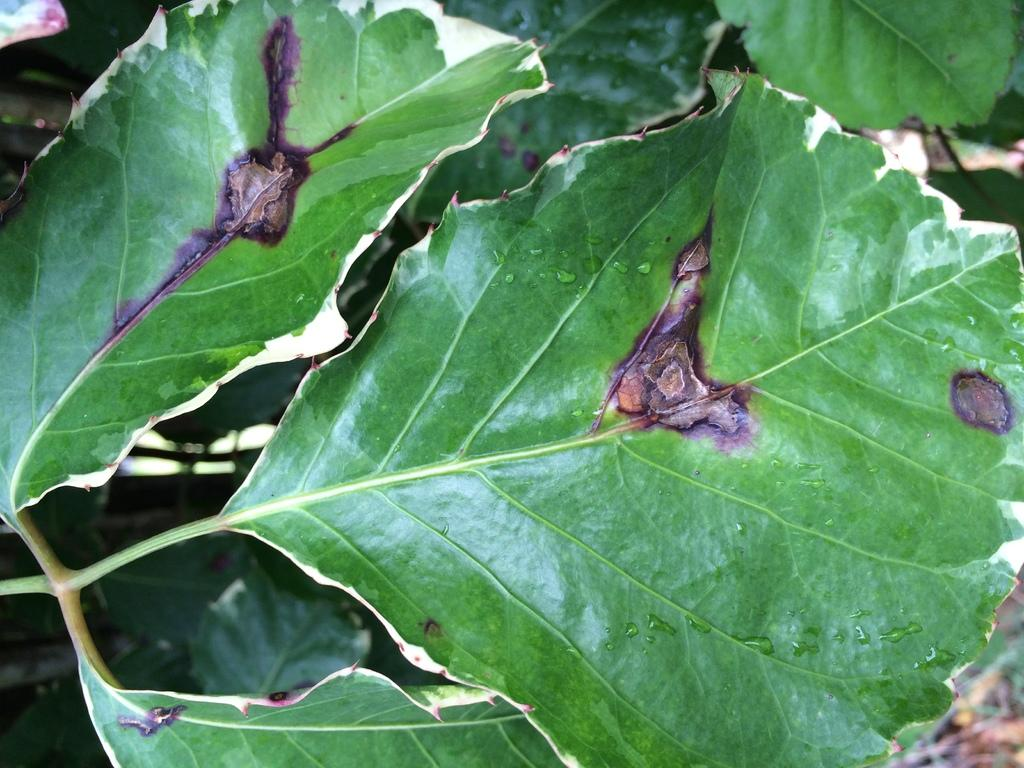What type of natural elements are present in the image? There are leaves of a tree in the image. What colors can be observed on the leaves in the image? The leaves have green, brown, and black colors. What can be seen in the background of the image? In the background, there are other leaves that are green in color. What type of cream is being used to guide the crib in the image? There is no cream, crib, or guiding action present in the image; it only features leaves of a tree with various colors. 